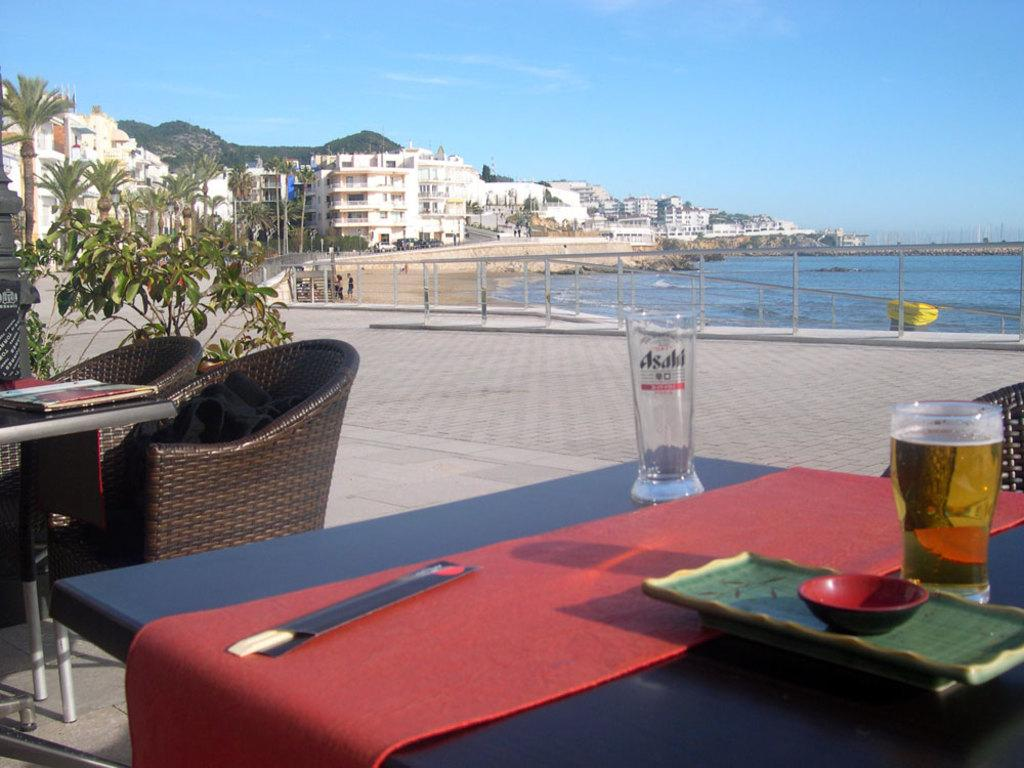What type of furniture can be seen in the image? There are tables and chairs in the image. What objects are placed on the tables? There are glasses on the table, and there is a tray with a bowl on the table. What can be seen in the background of the image? There are buildings, trees, sky, and water visible in the background of the image. What architectural feature is present in the background of the image? There are railings in the background of the image. What type of berry is growing on the railings in the image? There are no berries visible in the image, and the railings are not associated with any plants or vegetation. 